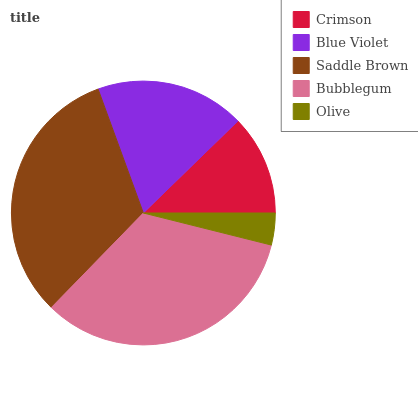Is Olive the minimum?
Answer yes or no. Yes. Is Bubblegum the maximum?
Answer yes or no. Yes. Is Blue Violet the minimum?
Answer yes or no. No. Is Blue Violet the maximum?
Answer yes or no. No. Is Blue Violet greater than Crimson?
Answer yes or no. Yes. Is Crimson less than Blue Violet?
Answer yes or no. Yes. Is Crimson greater than Blue Violet?
Answer yes or no. No. Is Blue Violet less than Crimson?
Answer yes or no. No. Is Blue Violet the high median?
Answer yes or no. Yes. Is Blue Violet the low median?
Answer yes or no. Yes. Is Bubblegum the high median?
Answer yes or no. No. Is Olive the low median?
Answer yes or no. No. 